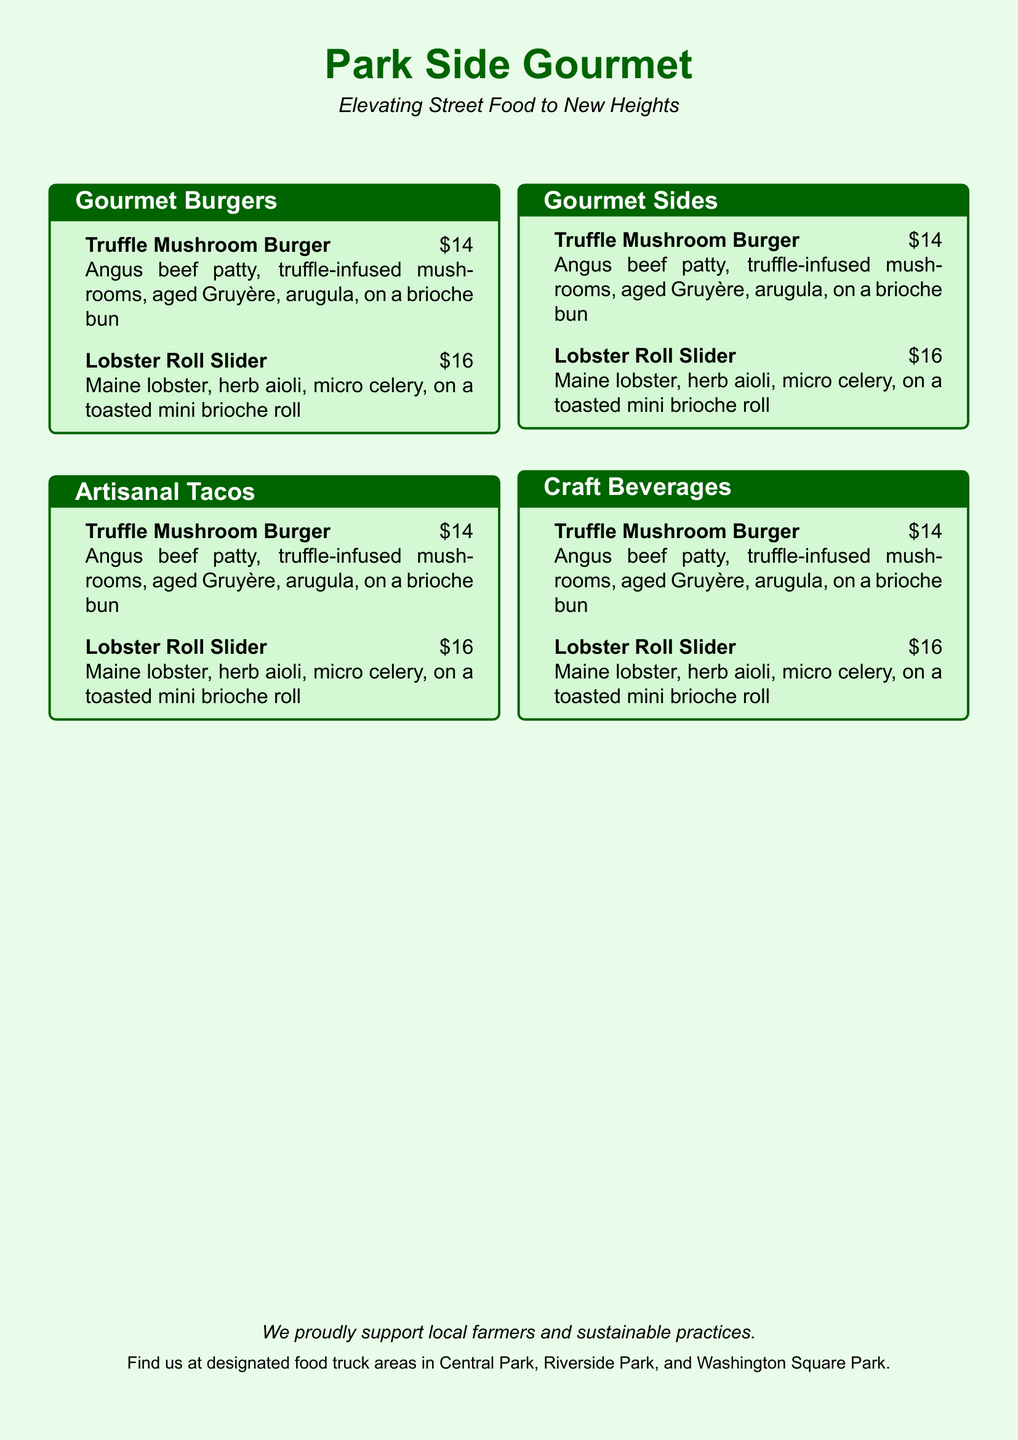what is the name of the food truck? The food truck is called "Park Side Gourmet," which is mentioned at the top of the document.
Answer: Park Side Gourmet what is the price of the Truffle Mushroom Burger? The price of the Truffle Mushroom Burger is listed next to its name in the menu.
Answer: $14 how many gourmet burger options are listed in the menu? The document explicitly lists two gourmet burger options under the Gourmet Burgers section.
Answer: 2 what type of seafood is used in the Lobster Roll Slider? The menu specifies that the Lobster Roll Slider uses Maine lobster, indicating the type of seafood.
Answer: Maine lobster what culinary approach does Park Side Gourmet emphasize? The tagline below the title highlights the restaurant's goal of enhancing street food offerings.
Answer: Elevating Street Food what is the ingredient that adds truffle flavor to the Truffle Mushroom Burger? The document states that truffle-infused mushrooms provide the truffle flavor in the burger.
Answer: truffle-infused mushrooms how does Park Side Gourmet support the community? The last line indicates their support for local farmers and sustainable practices, showing community involvement.
Answer: local farmers where can customers find the food truck? The document lists specific locations where the food truck operates, giving customers clear guidance.
Answer: Central Park, Riverside Park, Washington Square Park 